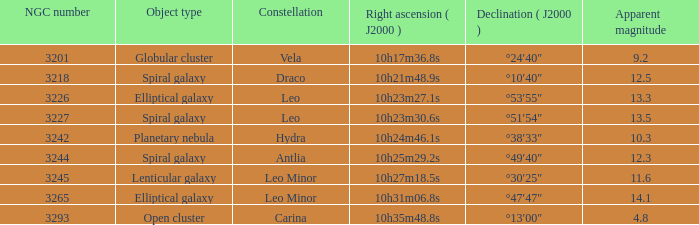What is the total of Apparent magnitudes for an NGC number larger than 3293? None. 